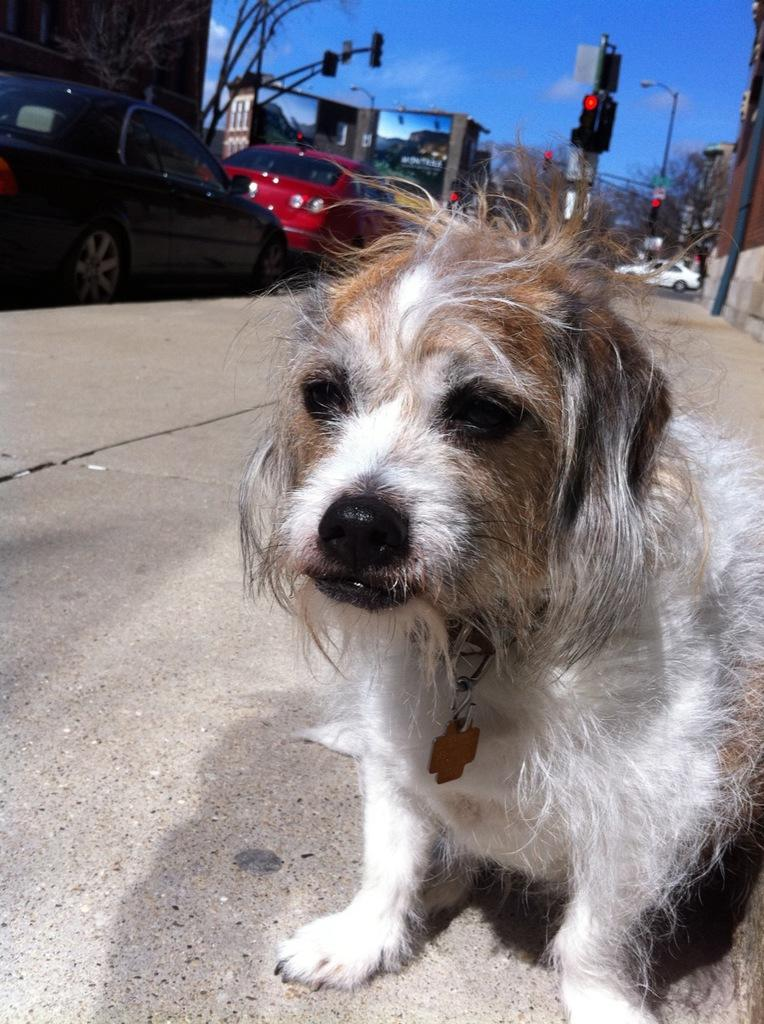What animal can be seen on the ground in the image? There is a dog on the ground in the image. What can be seen in the background of the image? There are cars parked on the road, traffic lights, buildings, and the sky visible in the background. What type of pie is being served at the building in the image? There is no pie or indication of a building serving food in the image. 